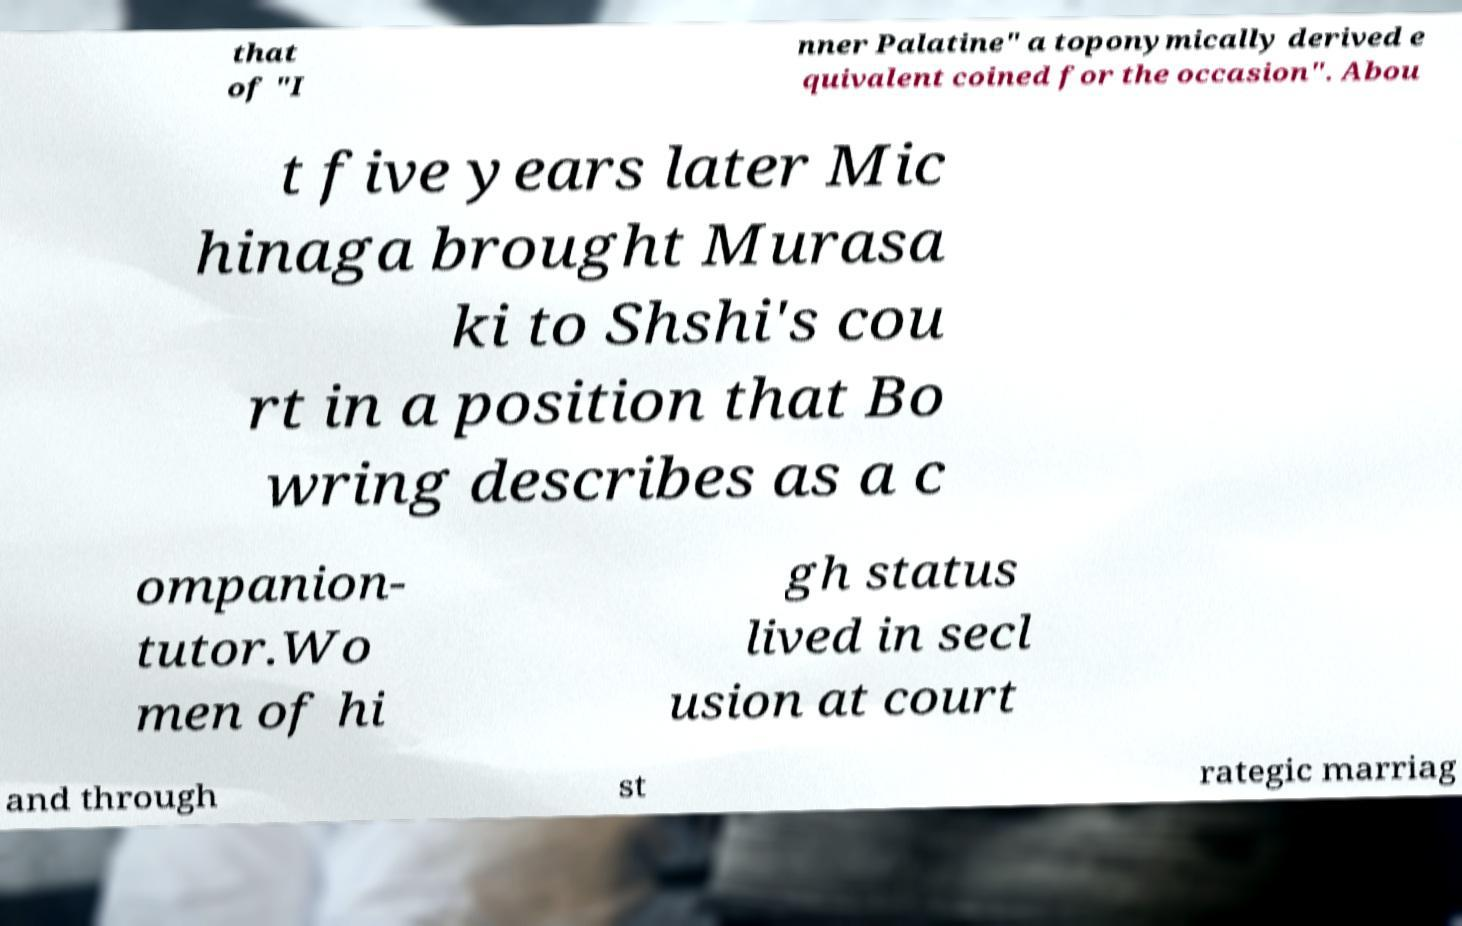Can you read and provide the text displayed in the image?This photo seems to have some interesting text. Can you extract and type it out for me? that of "I nner Palatine" a toponymically derived e quivalent coined for the occasion". Abou t five years later Mic hinaga brought Murasa ki to Shshi's cou rt in a position that Bo wring describes as a c ompanion- tutor.Wo men of hi gh status lived in secl usion at court and through st rategic marriag 